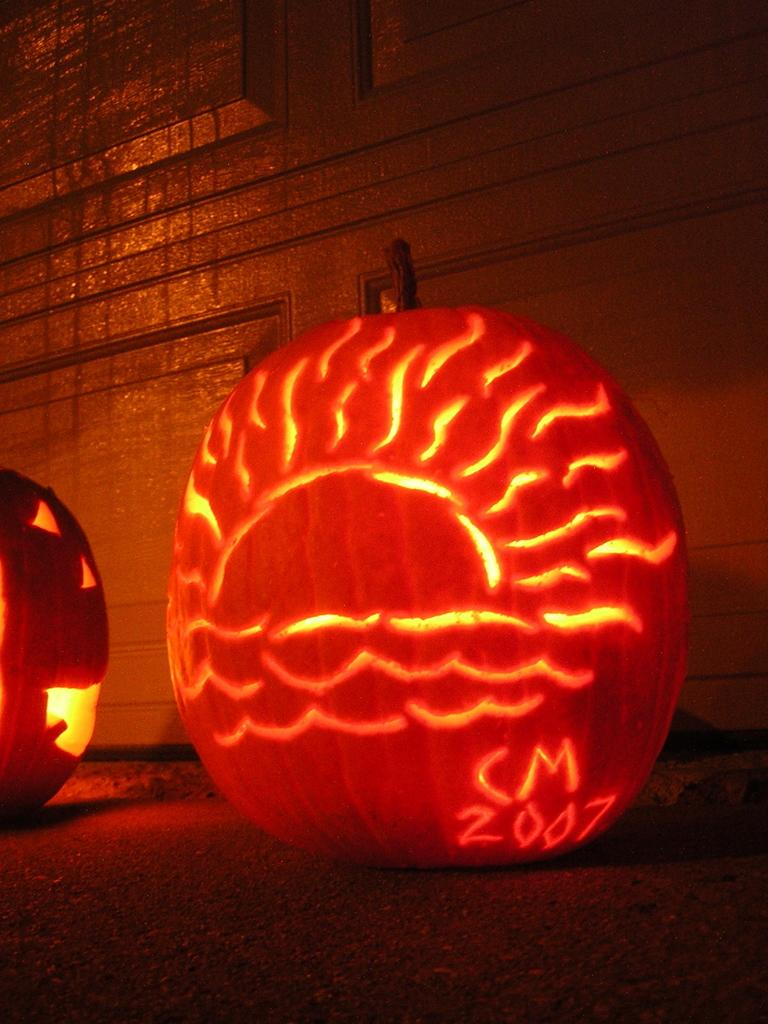What is the main subject in the center of the image? There is a pumpkin in the center of the image. What is unique about the pumpkin in the center? There is light inside the pumpkin. Are there any other pumpkins visible in the image? Yes, there is another pumpkin on the left side. What can be seen in the background of the image? There appears to be a wall in the background of the image. What type of crime is being committed in the image? There is no crime being committed in the image; it features pumpkins with light inside them. How is the distribution of pumpkins organized in the image? The distribution of pumpkins in the image is not mentioned, as there are only two visible pumpkins. 